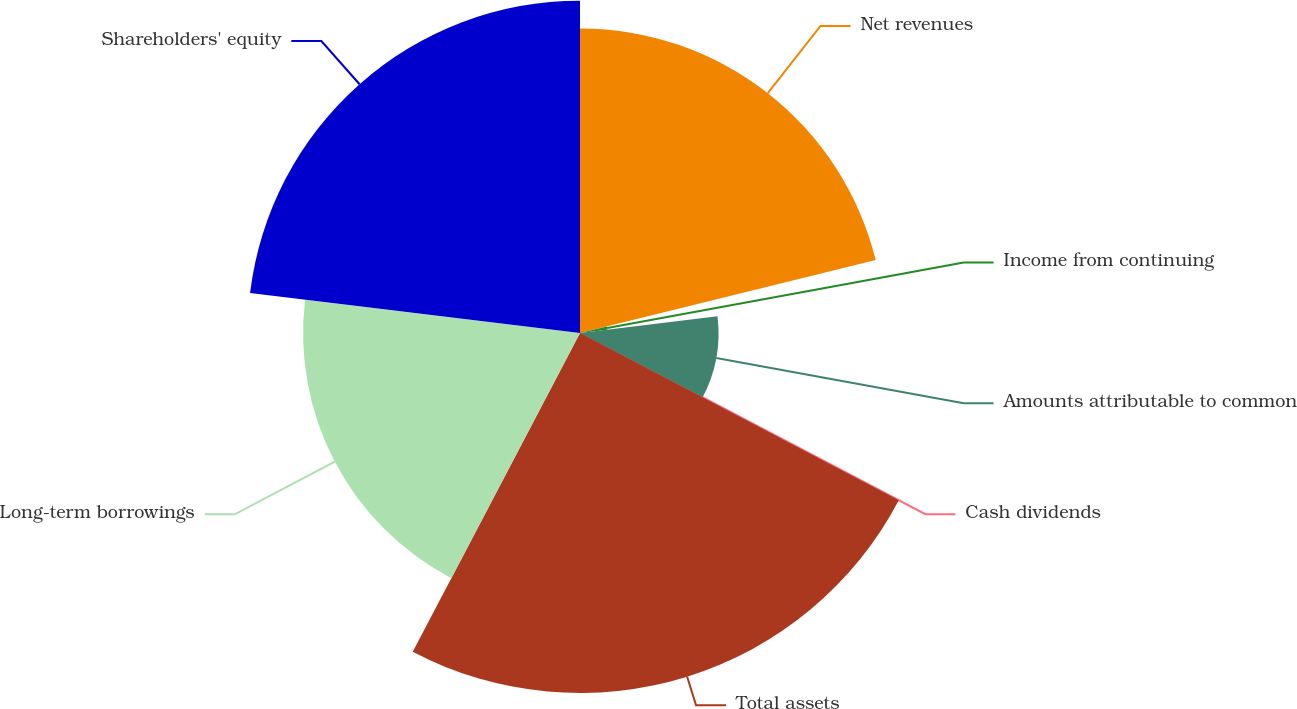Convert chart. <chart><loc_0><loc_0><loc_500><loc_500><pie_chart><fcel>Net revenues<fcel>Income from continuing<fcel>Amounts attributable to common<fcel>Cash dividends<fcel>Total assets<fcel>Long-term borrowings<fcel>Shareholders' equity<nl><fcel>21.15%<fcel>1.92%<fcel>9.62%<fcel>0.0%<fcel>25.0%<fcel>19.23%<fcel>23.08%<nl></chart> 